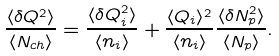Convert formula to latex. <formula><loc_0><loc_0><loc_500><loc_500>\frac { \langle \delta Q ^ { 2 } \rangle } { \langle N _ { c h } \rangle } = \frac { \langle \delta Q _ { i } ^ { 2 } \rangle } { \langle n _ { i } \rangle } + \frac { \langle Q _ { i } \rangle ^ { 2 } } { \langle n _ { i } \rangle } \frac { \langle \delta N _ { p } ^ { 2 } \rangle } { \langle N _ { p } \rangle } .</formula> 